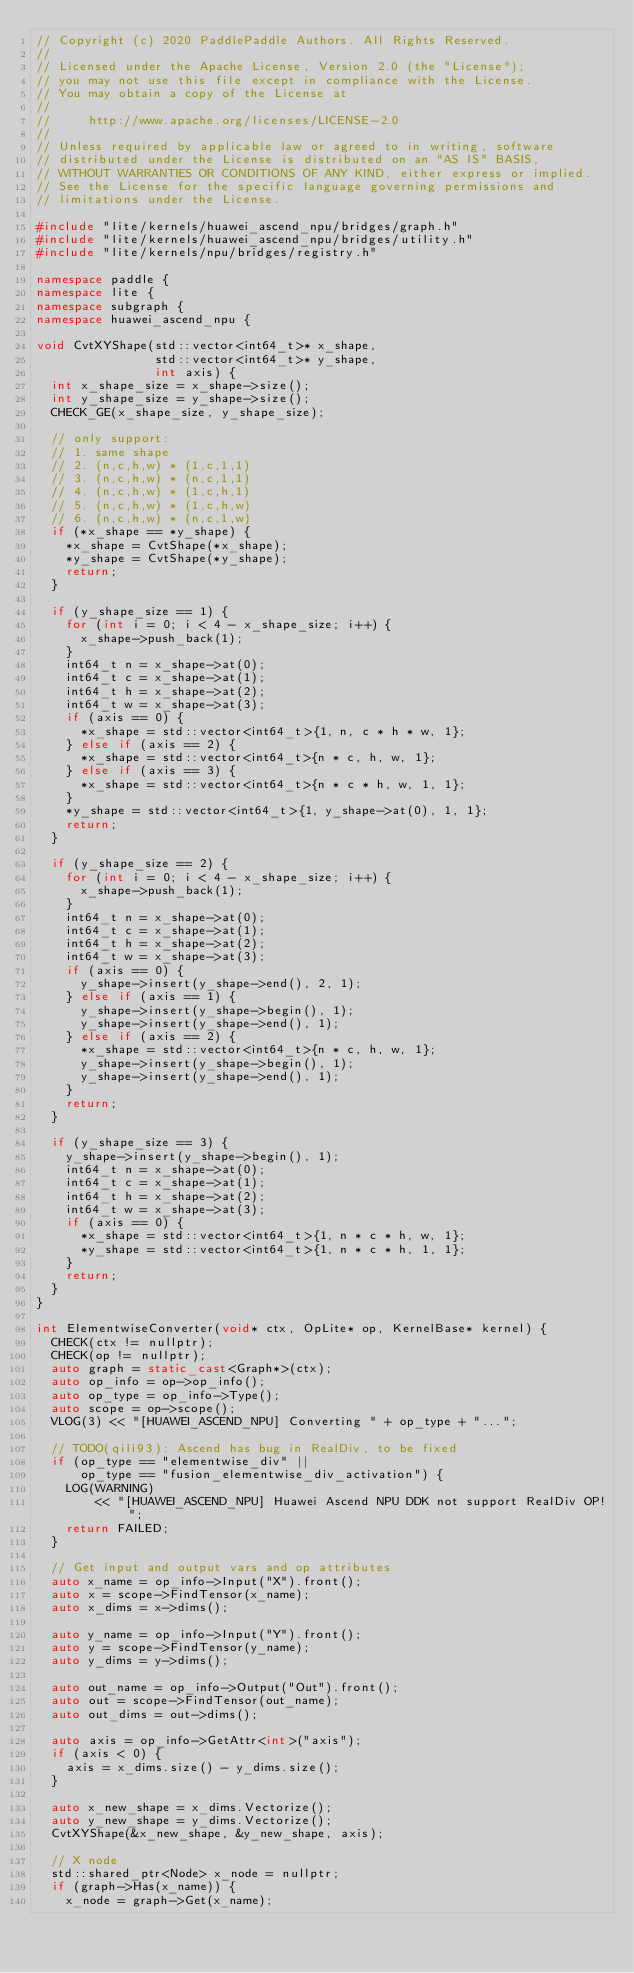Convert code to text. <code><loc_0><loc_0><loc_500><loc_500><_C++_>// Copyright (c) 2020 PaddlePaddle Authors. All Rights Reserved.
//
// Licensed under the Apache License, Version 2.0 (the "License");
// you may not use this file except in compliance with the License.
// You may obtain a copy of the License at
//
//     http://www.apache.org/licenses/LICENSE-2.0
//
// Unless required by applicable law or agreed to in writing, software
// distributed under the License is distributed on an "AS IS" BASIS,
// WITHOUT WARRANTIES OR CONDITIONS OF ANY KIND, either express or implied.
// See the License for the specific language governing permissions and
// limitations under the License.

#include "lite/kernels/huawei_ascend_npu/bridges/graph.h"
#include "lite/kernels/huawei_ascend_npu/bridges/utility.h"
#include "lite/kernels/npu/bridges/registry.h"

namespace paddle {
namespace lite {
namespace subgraph {
namespace huawei_ascend_npu {

void CvtXYShape(std::vector<int64_t>* x_shape,
                std::vector<int64_t>* y_shape,
                int axis) {
  int x_shape_size = x_shape->size();
  int y_shape_size = y_shape->size();
  CHECK_GE(x_shape_size, y_shape_size);

  // only support:
  // 1. same shape
  // 2. (n,c,h,w) * (1,c,1,1)
  // 3. (n,c,h,w) * (n,c,1,1)
  // 4. (n,c,h,w) * (1,c,h,1)
  // 5. (n,c,h,w) * (1,c,h,w)
  // 6. (n,c,h,w) * (n,c,1,w)
  if (*x_shape == *y_shape) {
    *x_shape = CvtShape(*x_shape);
    *y_shape = CvtShape(*y_shape);
    return;
  }

  if (y_shape_size == 1) {
    for (int i = 0; i < 4 - x_shape_size; i++) {
      x_shape->push_back(1);
    }
    int64_t n = x_shape->at(0);
    int64_t c = x_shape->at(1);
    int64_t h = x_shape->at(2);
    int64_t w = x_shape->at(3);
    if (axis == 0) {
      *x_shape = std::vector<int64_t>{1, n, c * h * w, 1};
    } else if (axis == 2) {
      *x_shape = std::vector<int64_t>{n * c, h, w, 1};
    } else if (axis == 3) {
      *x_shape = std::vector<int64_t>{n * c * h, w, 1, 1};
    }
    *y_shape = std::vector<int64_t>{1, y_shape->at(0), 1, 1};
    return;
  }

  if (y_shape_size == 2) {
    for (int i = 0; i < 4 - x_shape_size; i++) {
      x_shape->push_back(1);
    }
    int64_t n = x_shape->at(0);
    int64_t c = x_shape->at(1);
    int64_t h = x_shape->at(2);
    int64_t w = x_shape->at(3);
    if (axis == 0) {
      y_shape->insert(y_shape->end(), 2, 1);
    } else if (axis == 1) {
      y_shape->insert(y_shape->begin(), 1);
      y_shape->insert(y_shape->end(), 1);
    } else if (axis == 2) {
      *x_shape = std::vector<int64_t>{n * c, h, w, 1};
      y_shape->insert(y_shape->begin(), 1);
      y_shape->insert(y_shape->end(), 1);
    }
    return;
  }

  if (y_shape_size == 3) {
    y_shape->insert(y_shape->begin(), 1);
    int64_t n = x_shape->at(0);
    int64_t c = x_shape->at(1);
    int64_t h = x_shape->at(2);
    int64_t w = x_shape->at(3);
    if (axis == 0) {
      *x_shape = std::vector<int64_t>{1, n * c * h, w, 1};
      *y_shape = std::vector<int64_t>{1, n * c * h, 1, 1};
    }
    return;
  }
}

int ElementwiseConverter(void* ctx, OpLite* op, KernelBase* kernel) {
  CHECK(ctx != nullptr);
  CHECK(op != nullptr);
  auto graph = static_cast<Graph*>(ctx);
  auto op_info = op->op_info();
  auto op_type = op_info->Type();
  auto scope = op->scope();
  VLOG(3) << "[HUAWEI_ASCEND_NPU] Converting " + op_type + "...";

  // TODO(qili93): Ascend has bug in RealDiv, to be fixed
  if (op_type == "elementwise_div" ||
      op_type == "fusion_elementwise_div_activation") {
    LOG(WARNING)
        << "[HUAWEI_ASCEND_NPU] Huawei Ascend NPU DDK not support RealDiv OP!";
    return FAILED;
  }

  // Get input and output vars and op attributes
  auto x_name = op_info->Input("X").front();
  auto x = scope->FindTensor(x_name);
  auto x_dims = x->dims();

  auto y_name = op_info->Input("Y").front();
  auto y = scope->FindTensor(y_name);
  auto y_dims = y->dims();

  auto out_name = op_info->Output("Out").front();
  auto out = scope->FindTensor(out_name);
  auto out_dims = out->dims();

  auto axis = op_info->GetAttr<int>("axis");
  if (axis < 0) {
    axis = x_dims.size() - y_dims.size();
  }

  auto x_new_shape = x_dims.Vectorize();
  auto y_new_shape = y_dims.Vectorize();
  CvtXYShape(&x_new_shape, &y_new_shape, axis);

  // X node
  std::shared_ptr<Node> x_node = nullptr;
  if (graph->Has(x_name)) {
    x_node = graph->Get(x_name);</code> 